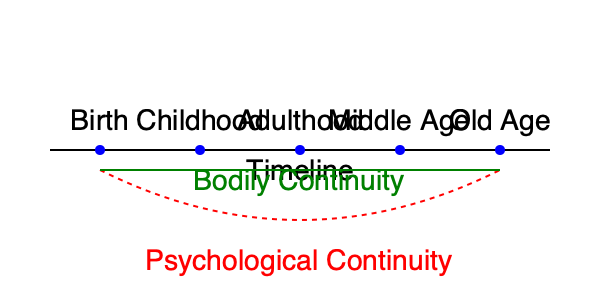Considering the timeline of personal identity depicted in the graphic, which philosophical theory best explains the persistence of self through various life stages, and why might this perspective be challenged? 1. The graphic presents two main theories of personal identity over time:
   a) Psychological Continuity (red dashed curve)
   b) Bodily Continuity (green straight line)

2. Psychological Continuity Theory:
   - Represented by the curved red line
   - Suggests that personal identity persists through psychological connections (memories, beliefs, desires)
   - Allows for gradual changes in personality and mental states over time

3. Bodily Continuity Theory:
   - Represented by the straight green line
   - Proposes that personal identity is maintained through physical continuity of the body
   - Emphasizes the importance of material persistence

4. The question asks which theory best explains personal identity persistence:
   - Psychological Continuity is often favored in contemporary philosophy
   - It accounts for significant changes in physical appearance and even some bodily changes

5. Challenges to Psychological Continuity:
   a) Memory loss or radical personality changes (e.g., due to brain injury)
   b) Thought experiments like teleportation or mind uploading
   c) Questions about the nature of consciousness and its relation to the physical brain

6. Potential synthesis:
   - Some philosophers argue for a combination of both theories
   - Personal identity might require both psychological and bodily continuity to some degree

7. Conclusion:
   Psychological Continuity Theory generally provides a more robust explanation for personal identity over time, as it accounts for the intuitive sense of self that persists despite physical changes. However, it faces challenges in extreme cases and may need to be complemented by aspects of Bodily Continuity Theory.
Answer: Psychological Continuity Theory, but it faces challenges in extreme cases. 